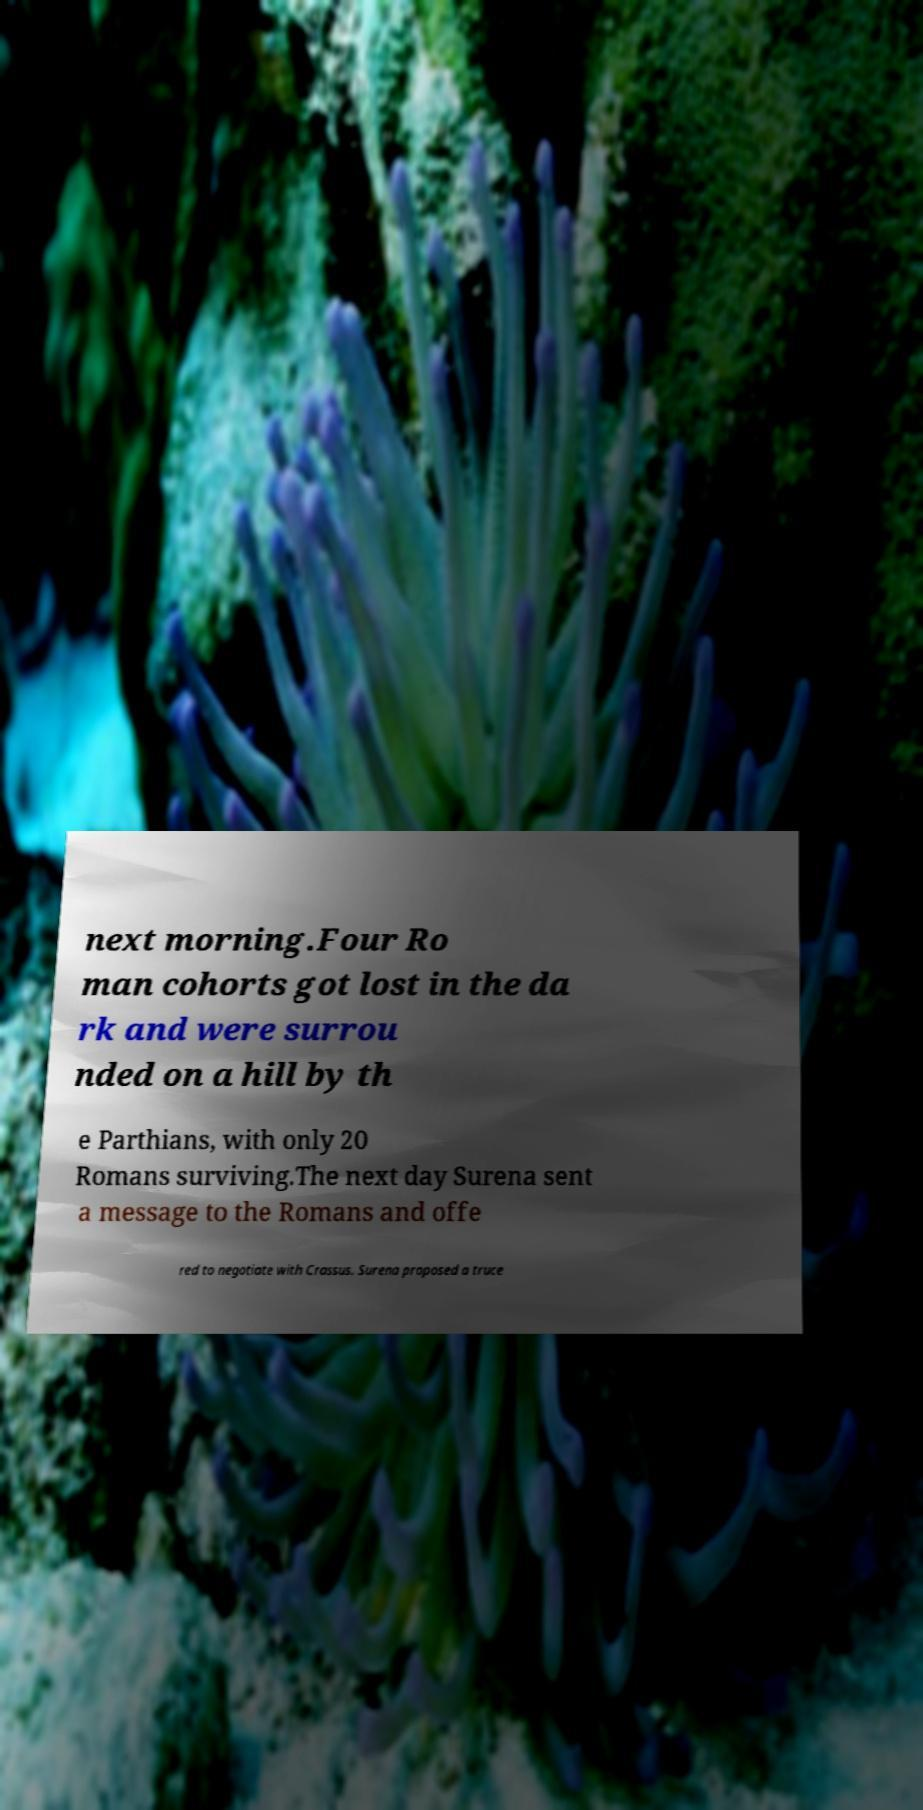Can you accurately transcribe the text from the provided image for me? next morning.Four Ro man cohorts got lost in the da rk and were surrou nded on a hill by th e Parthians, with only 20 Romans surviving.The next day Surena sent a message to the Romans and offe red to negotiate with Crassus. Surena proposed a truce 